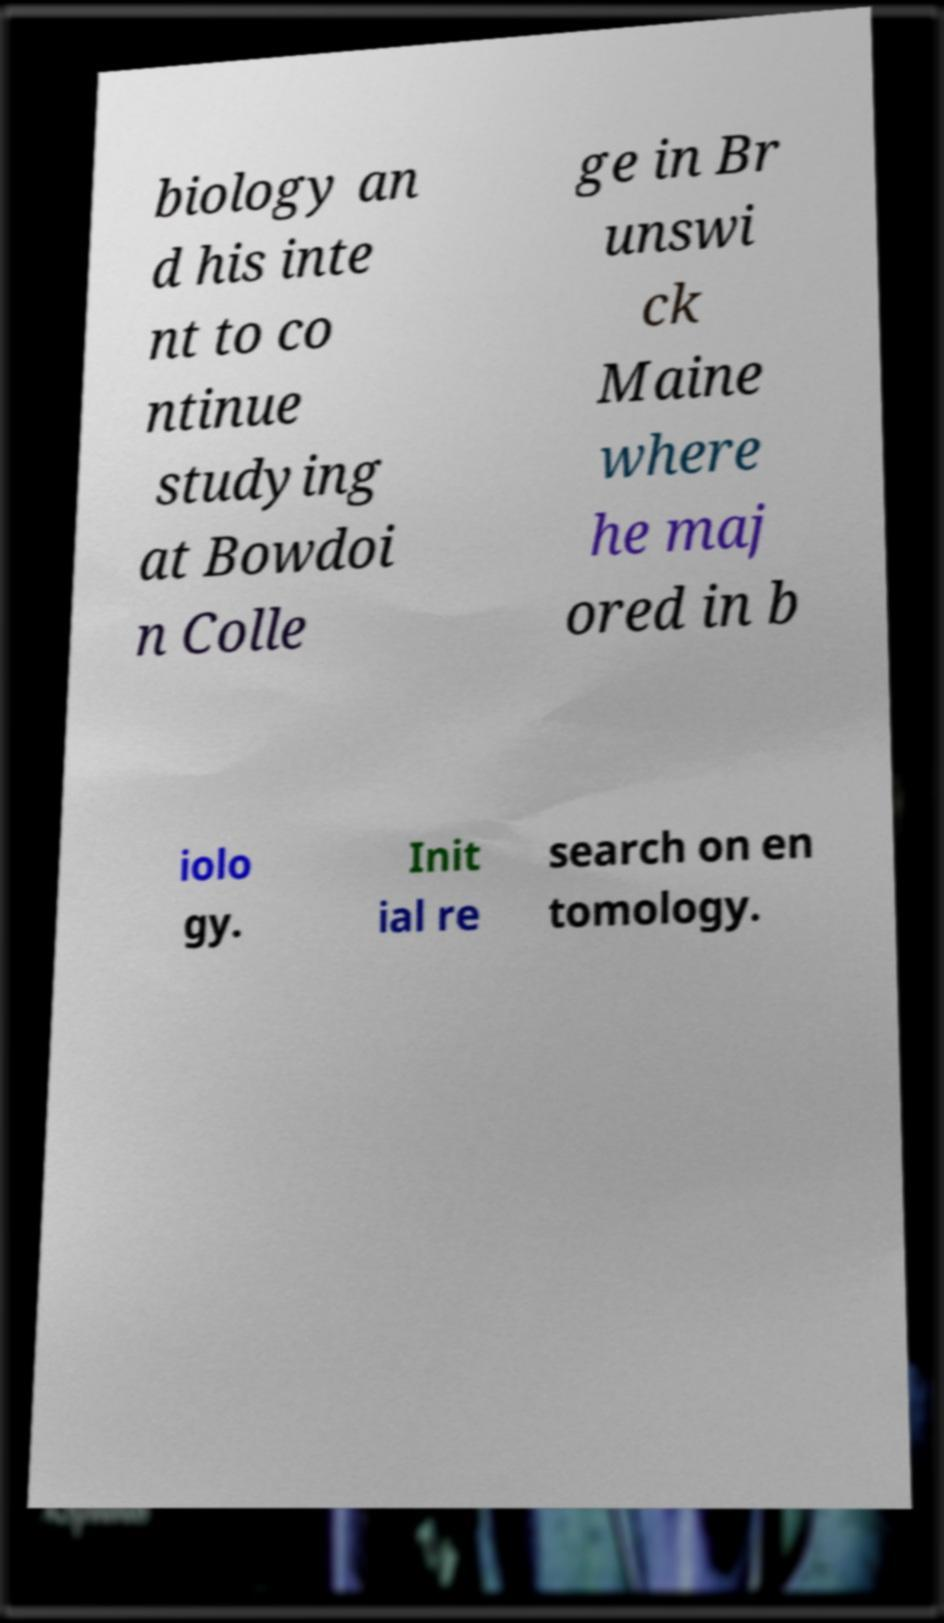I need the written content from this picture converted into text. Can you do that? biology an d his inte nt to co ntinue studying at Bowdoi n Colle ge in Br unswi ck Maine where he maj ored in b iolo gy. Init ial re search on en tomology. 